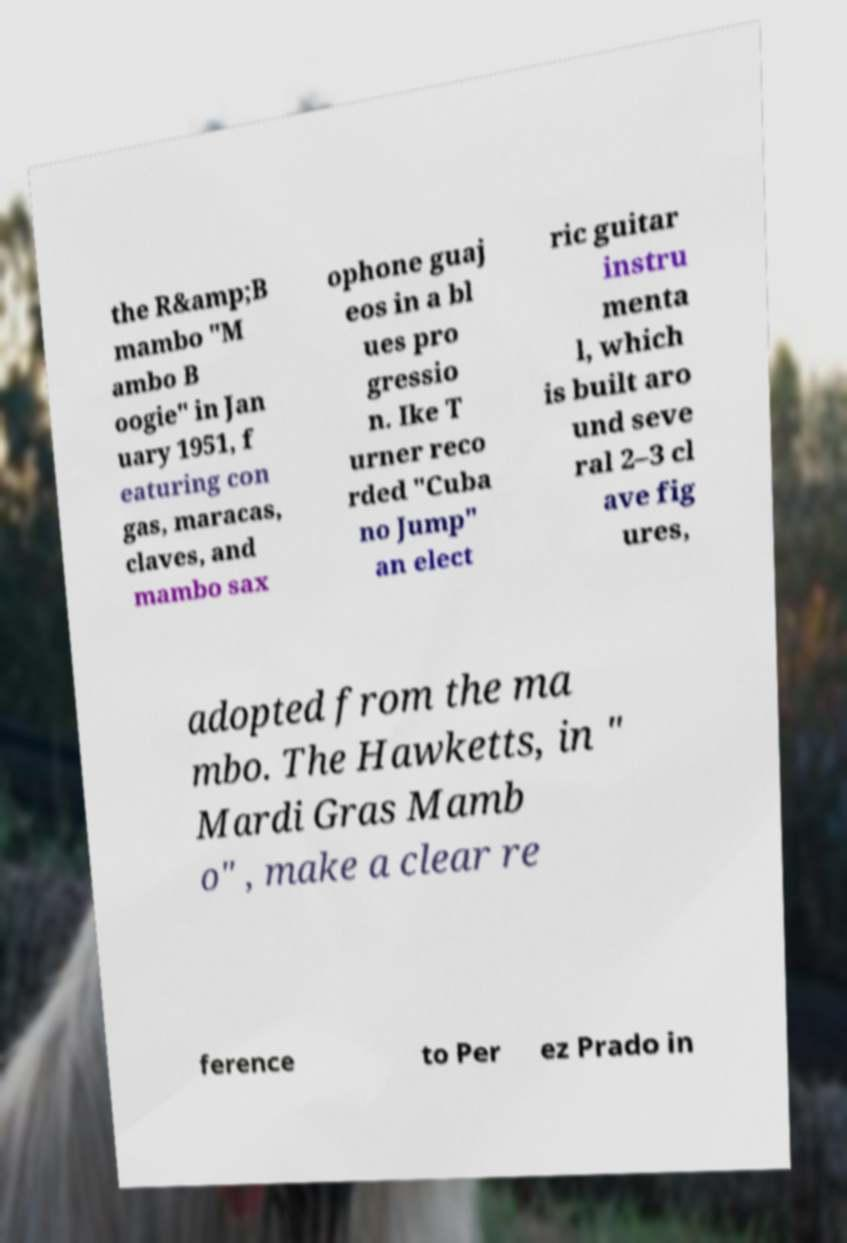I need the written content from this picture converted into text. Can you do that? the R&amp;B mambo "M ambo B oogie" in Jan uary 1951, f eaturing con gas, maracas, claves, and mambo sax ophone guaj eos in a bl ues pro gressio n. Ike T urner reco rded "Cuba no Jump" an elect ric guitar instru menta l, which is built aro und seve ral 2–3 cl ave fig ures, adopted from the ma mbo. The Hawketts, in " Mardi Gras Mamb o" , make a clear re ference to Per ez Prado in 